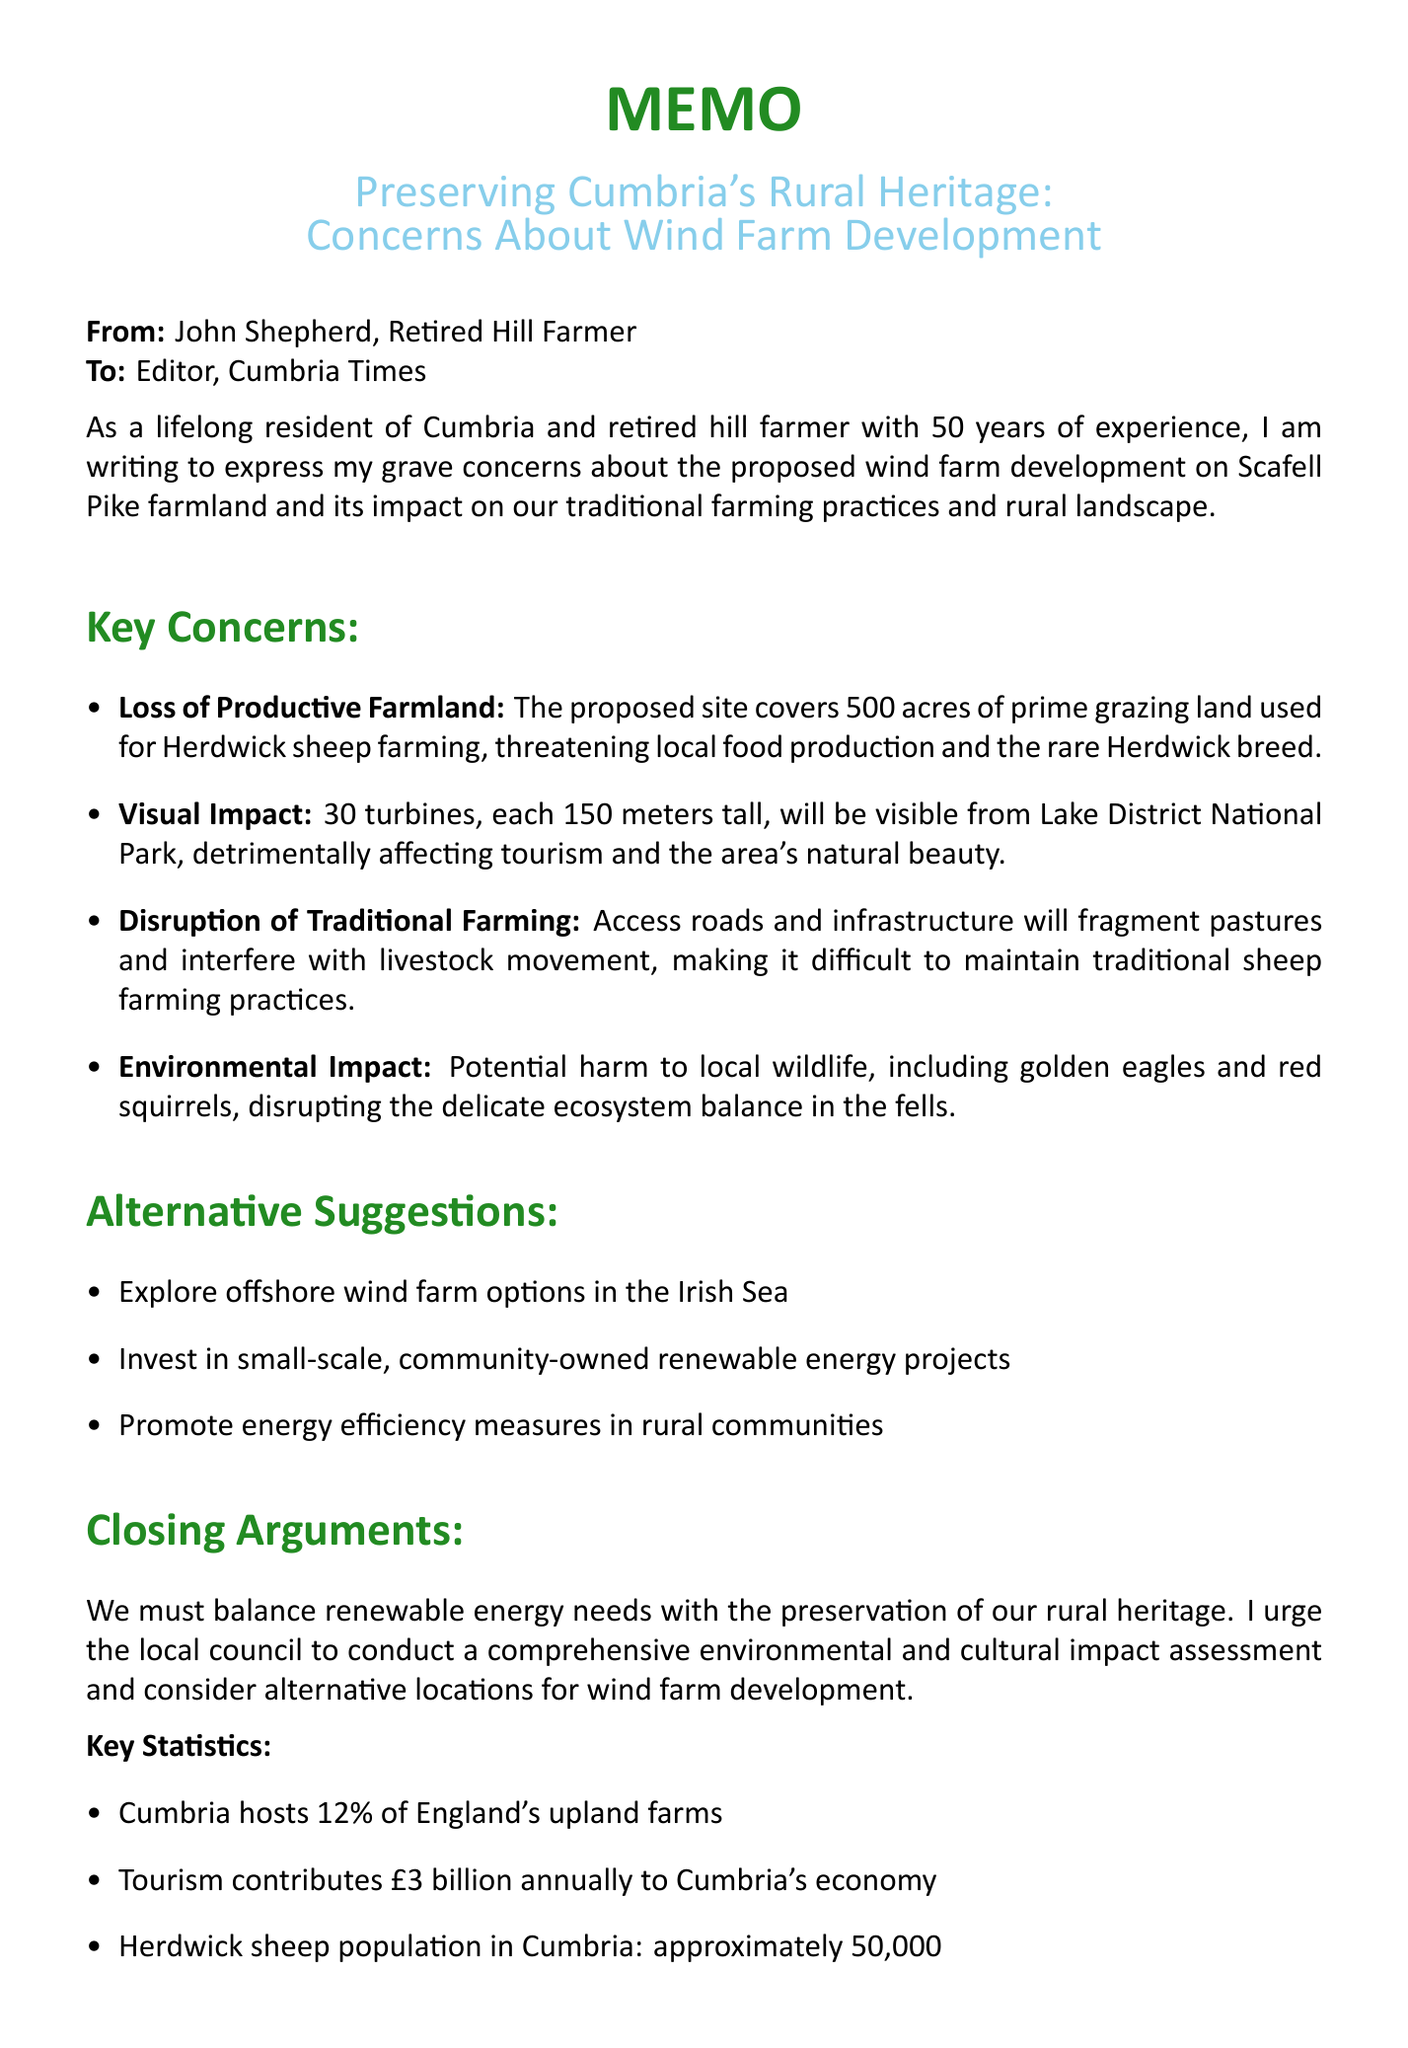what is the title of the letter? The title of the letter is clearly stated at the beginning of the document, emphasizing concerns about wind farm development.
Answer: Preserving Cumbria's Rural Heritage: Concerns About Wind Farm Development how many years of farming experience does the author have? The author mentions his experience explicitly as he describes himself in the introduction.
Answer: 50 years what is the size of the proposed wind farm site? The size of the proposed site is mentioned as it poses a significant concern in the document.
Answer: 500 acres which breed of sheep is specifically mentioned as being threatened? The document highlights the specific breed of sheep affected by the wind farm development as part of the concerns.
Answer: Herdwick how tall will the wind turbines be? The height of the turbines is stated to illustrate the visual impact on the landscape.
Answer: 150 meters what alternative energy suggestion involves the Irish Sea? One of the suggestions provided in the document involves exploring alternative locations for wind energy.
Answer: offshore wind farm options in the Irish Sea what is one key statistic about tourism's contribution to Cumbria's economy? Key statistics provided in the document highlight important aspects of Cumbria’s economy related to tourism.
Answer: £3 billion what organization is associated with farmers in this document? The document lists relevant organizations that relate to the concerns being addressed, and one pertains specifically to farmers.
Answer: National Farmers' Union (NFU) what is the author's name as stated in the signature block? The signature block shows the author's name for identification purposes at the end of the memo.
Answer: John Shepherd 